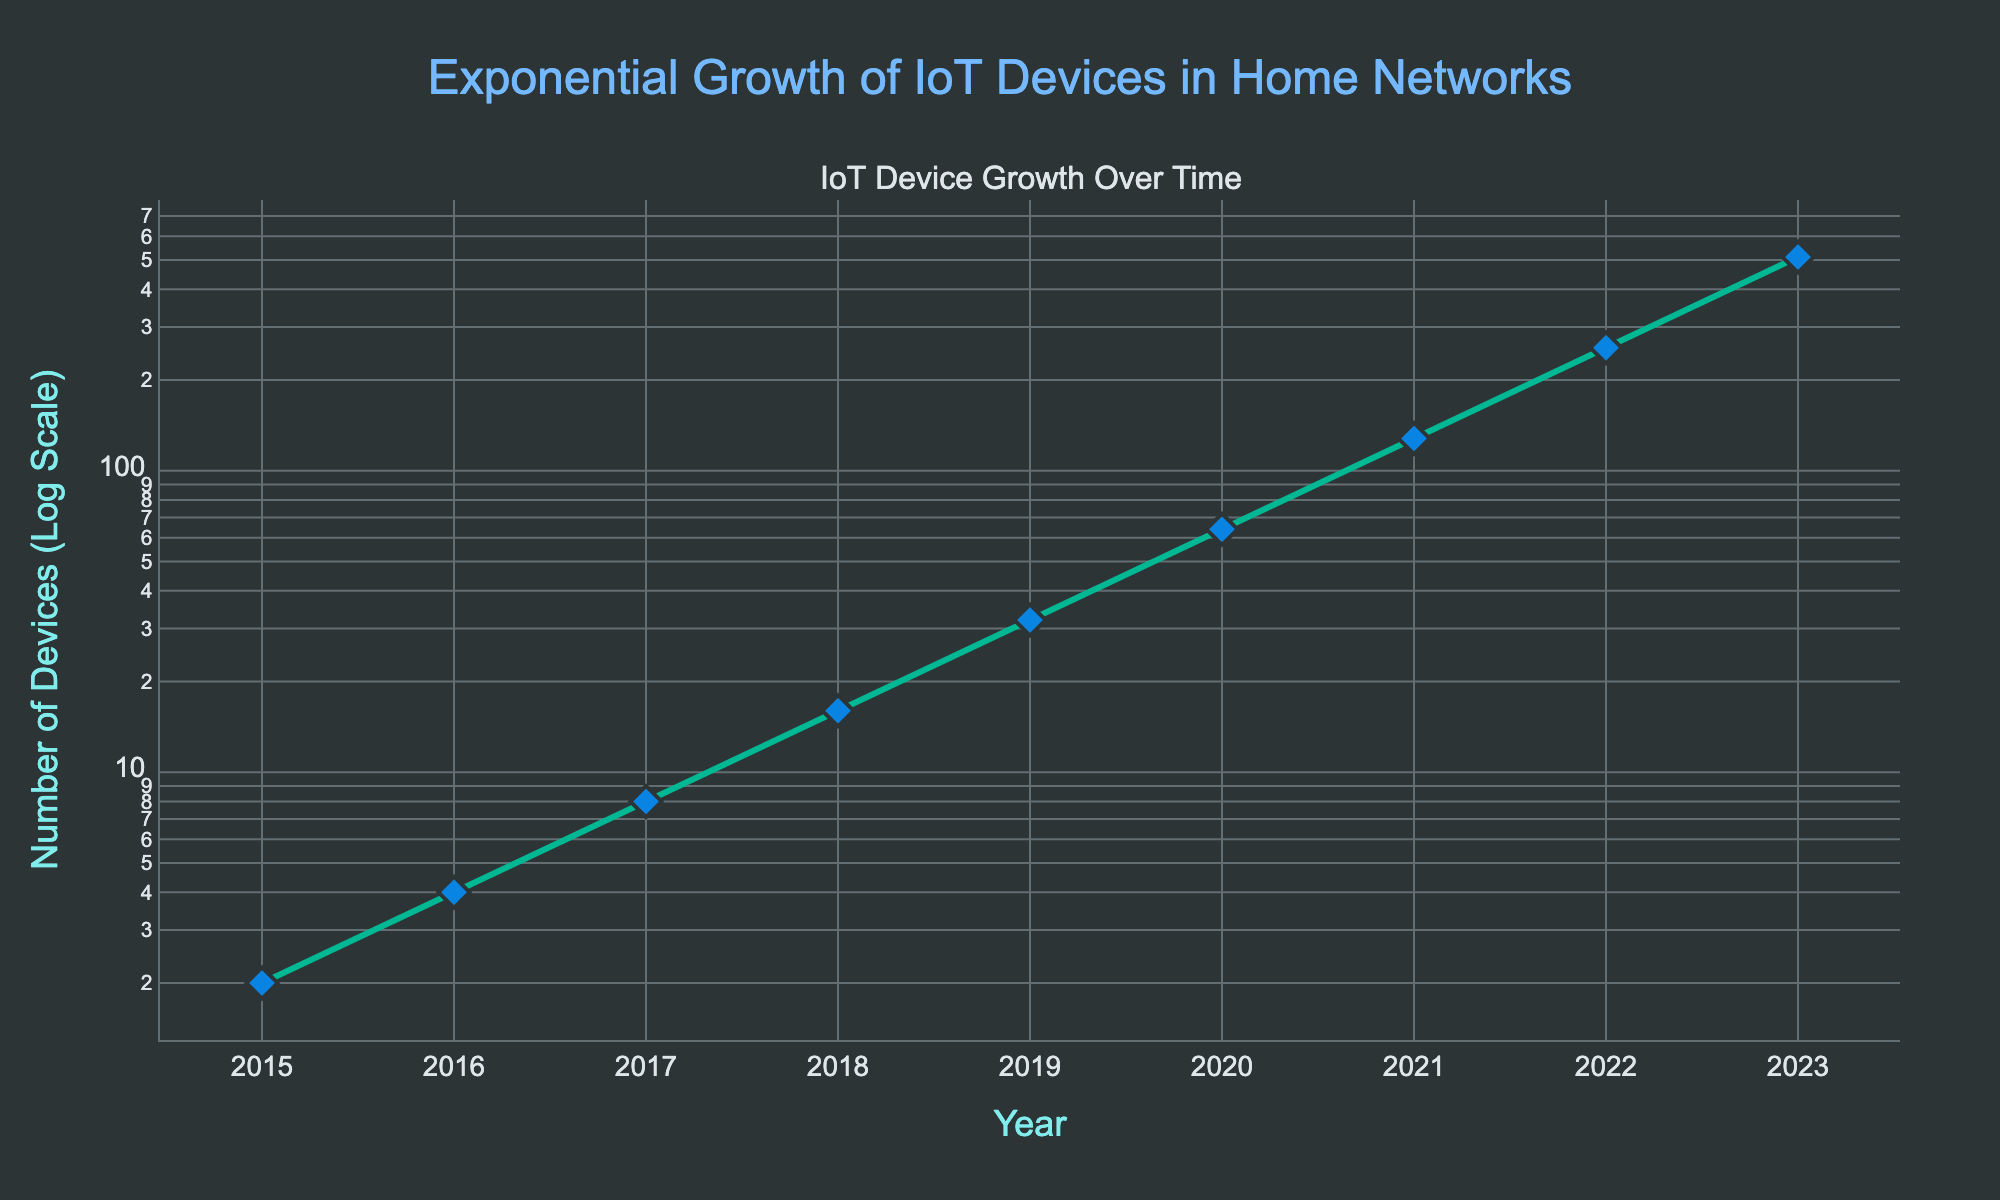What is the title of the plot? The title of the plot is positioned at the top center of the figure and is displayed prominently in a larger font size and a different color.
Answer: Exponential Growth of IoT Devices in Home Networks How many data points are plotted? The data points are shown as diamond markers connected by lines. By counting these markers, we can identify the number of data points.
Answer: 9 What is the number of IoT devices in 2023? The figure includes an annotation pointing out the number of IoT devices in 2023.
Answer: 512 What is the color of the line connecting the data points? The line color connecting the data points can be directly observed by looking at the plot tracing the growth over time.
Answer: Green How does the number of IoT devices change from 2018 to 2020? To find this, look at the number of IoT devices in 2018 and 2020 and calculate the difference. In 2018 it is 16, and in 2020 it is 64. Subtract 16 from 64.
Answer: Increased by 48 By how much does the number of IoT devices grow on average per year from 2015 to 2023? To find the average annual growth, compute the total growth from 2 to 512 (510 devices) over 8 years (2023 - 2015). Divide the total growth by the number of years.
Answer: 63.75 devices per year Which year has the largest number of IoT devices? Observing the x-axis and the data points, the year with the highest y-value (number of devices) is 2023.
Answer: 2023 How does the number of devices in 2019 compare to the number of devices in 2022? Look at the corresponding y-values for 2019 and 2022. The number of devices in 2019 is 32, while in 2022 it is 256. Compare these numbers to see which is larger.
Answer: 2022 has more devices What is the pattern of growth shown in the figure? The y-axis uses a logarithmic scale, and the number of devices increases exponentially over the years, as indicated by the steeply rising line.
Answer: Exponential growth At what rate does the number of IoT devices double? By analyzing the data points, every year the number of devices doubles. So, the rate at which the IoT devices double is once every year.
Answer: Once every year 